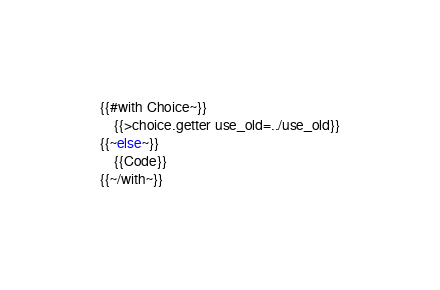<code> <loc_0><loc_0><loc_500><loc_500><_Rust_>{{#with Choice~}}
    {{>choice.getter use_old=../use_old}}
{{~else~}}
    {{Code}}
{{~/with~}}
</code> 